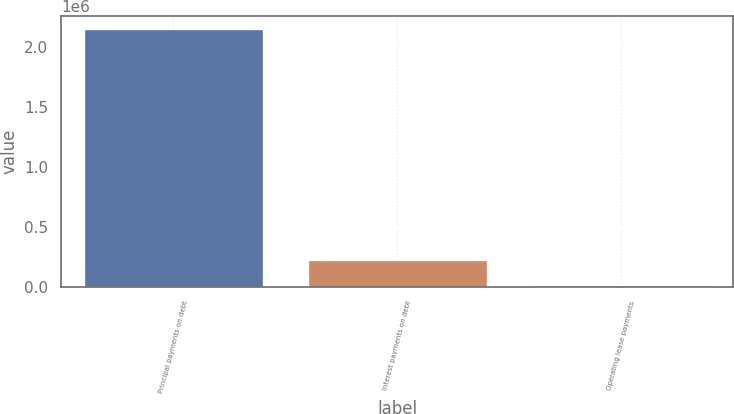Convert chart. <chart><loc_0><loc_0><loc_500><loc_500><bar_chart><fcel>Principal payments on debt<fcel>Interest payments on debt<fcel>Operating lease payments<nl><fcel>2.14578e+06<fcel>227088<fcel>13900<nl></chart> 